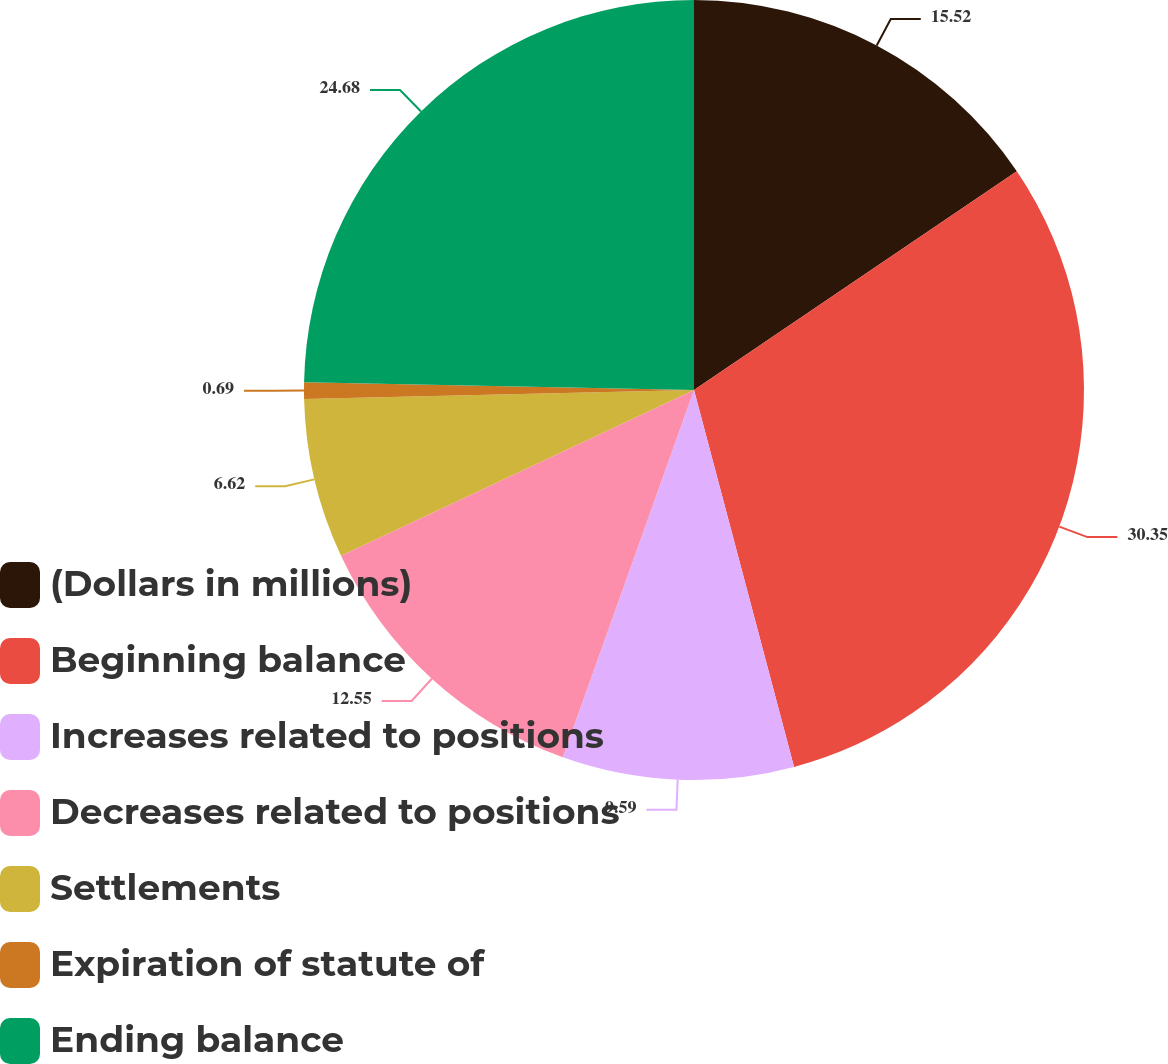Convert chart to OTSL. <chart><loc_0><loc_0><loc_500><loc_500><pie_chart><fcel>(Dollars in millions)<fcel>Beginning balance<fcel>Increases related to positions<fcel>Decreases related to positions<fcel>Settlements<fcel>Expiration of statute of<fcel>Ending balance<nl><fcel>15.52%<fcel>30.35%<fcel>9.59%<fcel>12.55%<fcel>6.62%<fcel>0.69%<fcel>24.68%<nl></chart> 